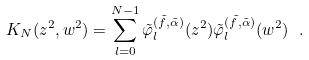<formula> <loc_0><loc_0><loc_500><loc_500>K _ { N } ( z ^ { 2 } , w ^ { 2 } ) = \sum _ { l = 0 } ^ { N - 1 } \tilde { \varphi } _ { l } ^ { ( \tilde { f } , \tilde { \alpha } ) } ( z ^ { 2 } ) \tilde { \varphi } _ { l } ^ { ( \tilde { f } , \tilde { \alpha } ) } ( w ^ { 2 } ) \ .</formula> 